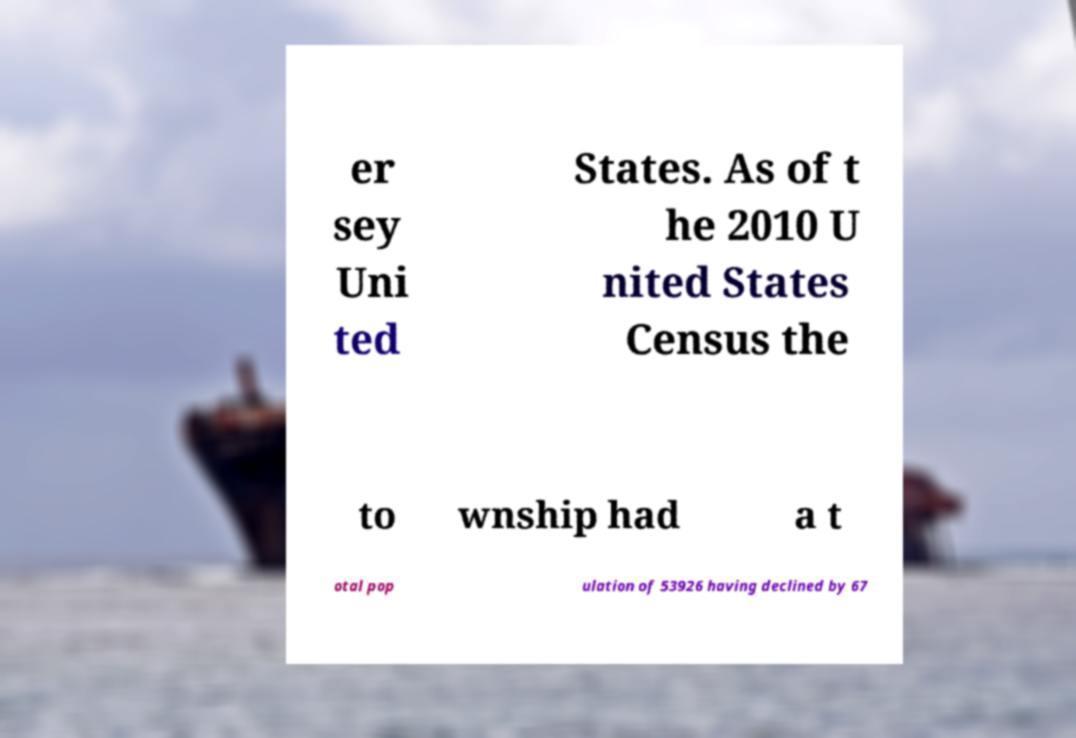Can you accurately transcribe the text from the provided image for me? er sey Uni ted States. As of t he 2010 U nited States Census the to wnship had a t otal pop ulation of 53926 having declined by 67 